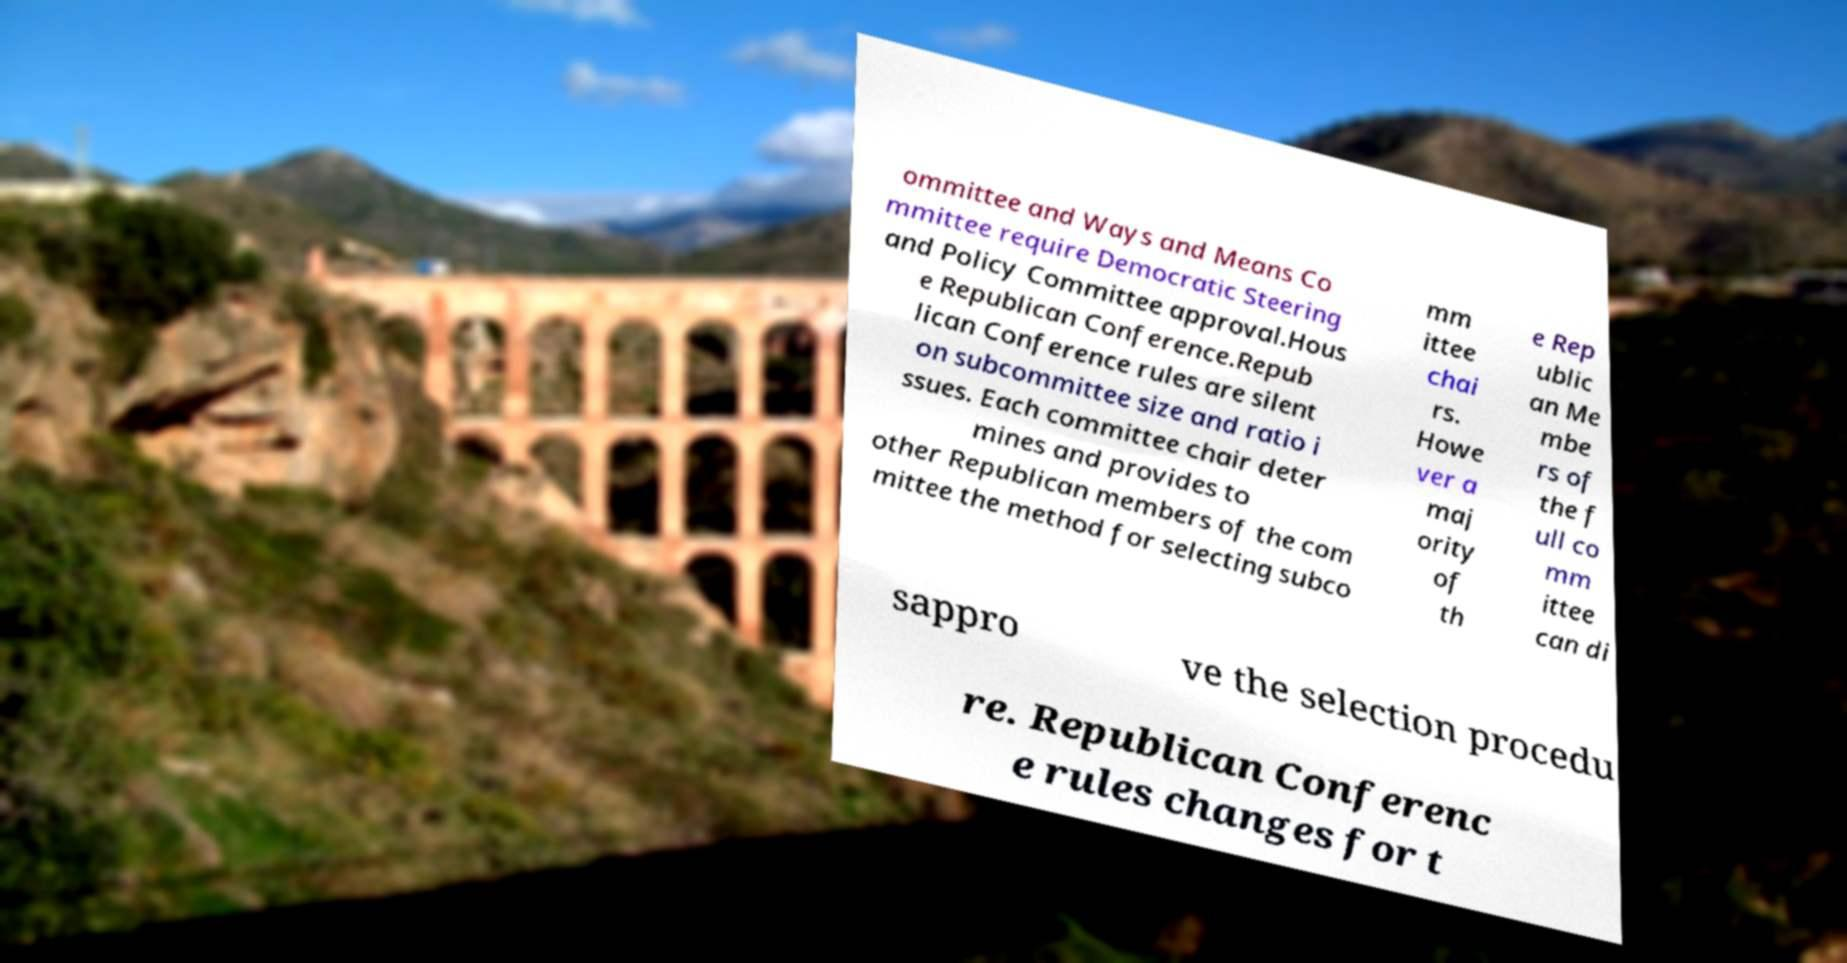There's text embedded in this image that I need extracted. Can you transcribe it verbatim? ommittee and Ways and Means Co mmittee require Democratic Steering and Policy Committee approval.Hous e Republican Conference.Repub lican Conference rules are silent on subcommittee size and ratio i ssues. Each committee chair deter mines and provides to other Republican members of the com mittee the method for selecting subco mm ittee chai rs. Howe ver a maj ority of th e Rep ublic an Me mbe rs of the f ull co mm ittee can di sappro ve the selection procedu re. Republican Conferenc e rules changes for t 